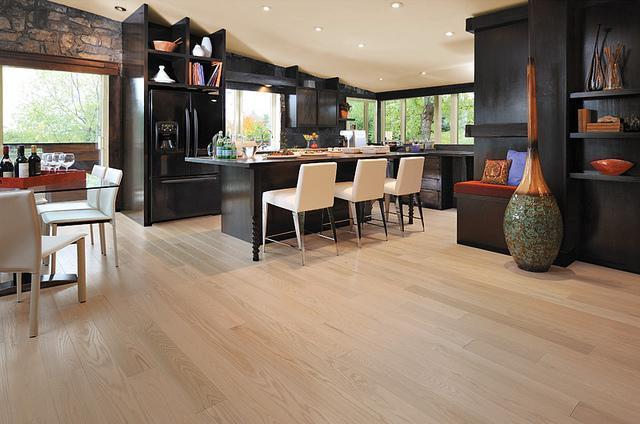How many chairs can be seen?
Give a very brief answer. 5. How many dining tables are there?
Give a very brief answer. 2. How many sets of train tracks are here?
Give a very brief answer. 0. 